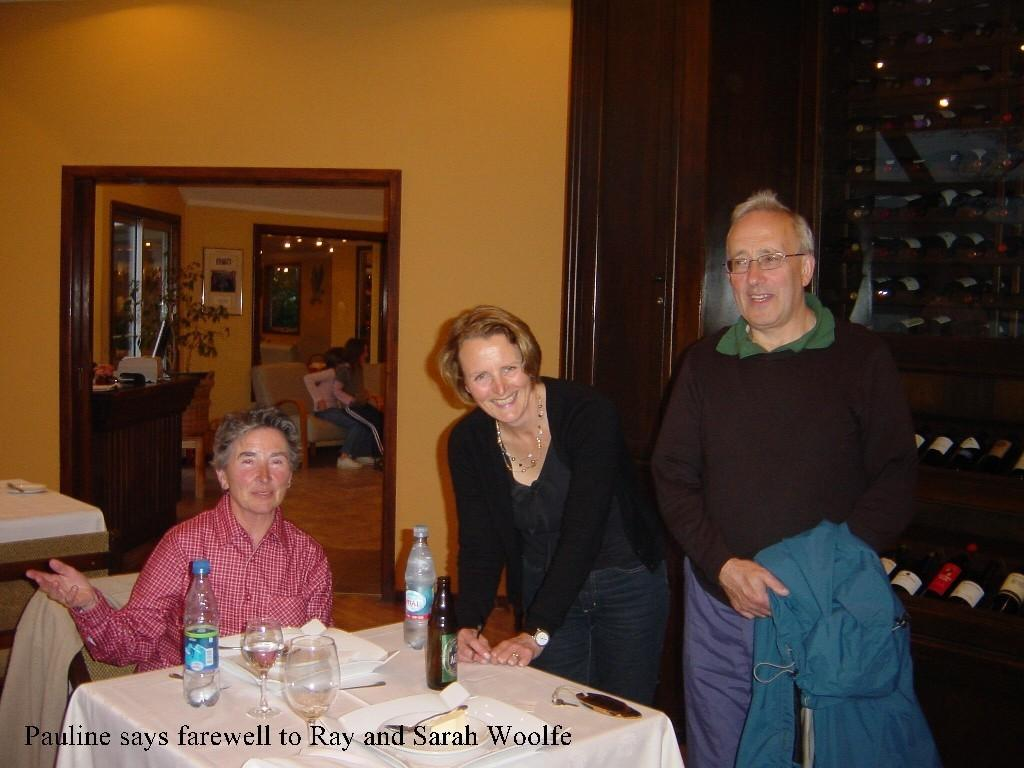How many people are in the image? There is a group of people in the image. What are the positions of the people in the image? Two persons are standing, and three persons are sitting on chairs. What expressions do the standing persons have? The standing persons are smiling. What can be seen in the background of the image? There is a wall, a window, and a cupboard in the background of the image. What type of breakfast is being served on the tray in the image? There is no tray or breakfast present in the image. Can you tell me how many toes the person on the left has? There is no person's toes visible in the image. 